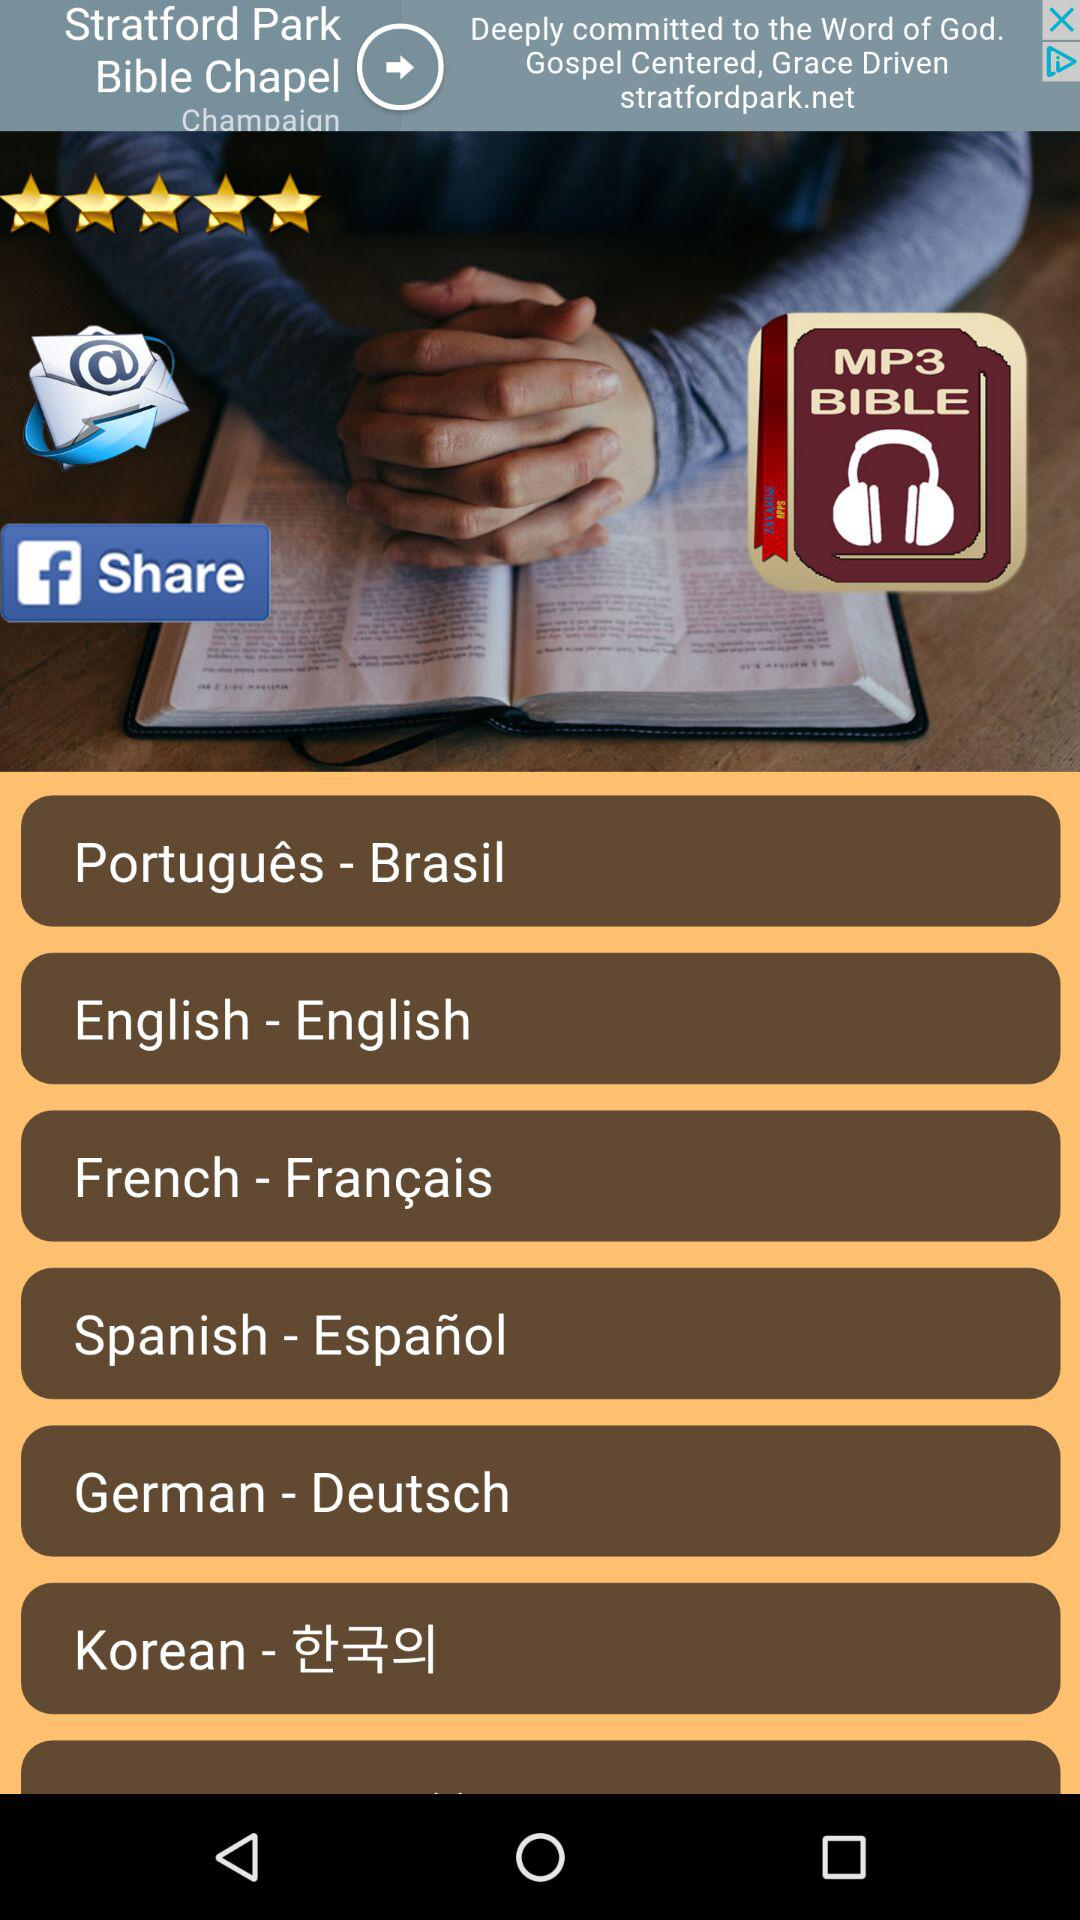What is the name of the application? The name of the application is "MP3 BIBLE". 